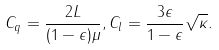<formula> <loc_0><loc_0><loc_500><loc_500>C _ { q } = \frac { 2 L } { ( 1 - \epsilon ) \mu } , C _ { l } = \frac { 3 \epsilon } { 1 - \epsilon } \sqrt { \kappa } .</formula> 